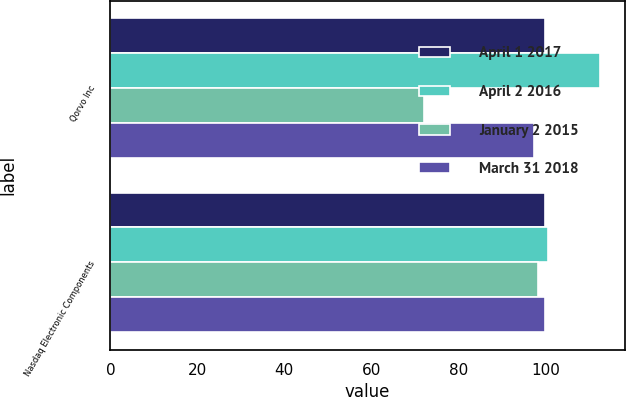<chart> <loc_0><loc_0><loc_500><loc_500><stacked_bar_chart><ecel><fcel>Qorvo Inc<fcel>Nasdaq Electronic Components<nl><fcel>April 1 2017<fcel>100<fcel>100<nl><fcel>April 2 2016<fcel>112.61<fcel>100.63<nl><fcel>January 2 2015<fcel>72.19<fcel>98.26<nl><fcel>March 31 2018<fcel>97.39<fcel>100<nl></chart> 